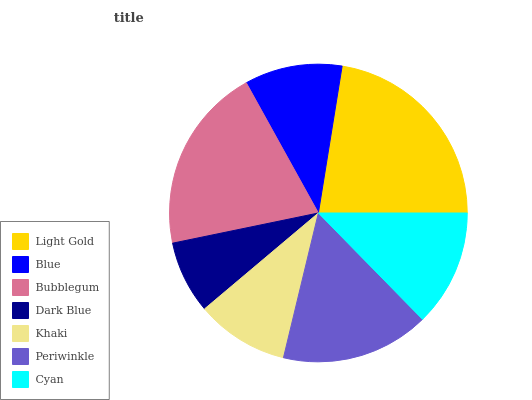Is Dark Blue the minimum?
Answer yes or no. Yes. Is Light Gold the maximum?
Answer yes or no. Yes. Is Blue the minimum?
Answer yes or no. No. Is Blue the maximum?
Answer yes or no. No. Is Light Gold greater than Blue?
Answer yes or no. Yes. Is Blue less than Light Gold?
Answer yes or no. Yes. Is Blue greater than Light Gold?
Answer yes or no. No. Is Light Gold less than Blue?
Answer yes or no. No. Is Cyan the high median?
Answer yes or no. Yes. Is Cyan the low median?
Answer yes or no. Yes. Is Khaki the high median?
Answer yes or no. No. Is Dark Blue the low median?
Answer yes or no. No. 